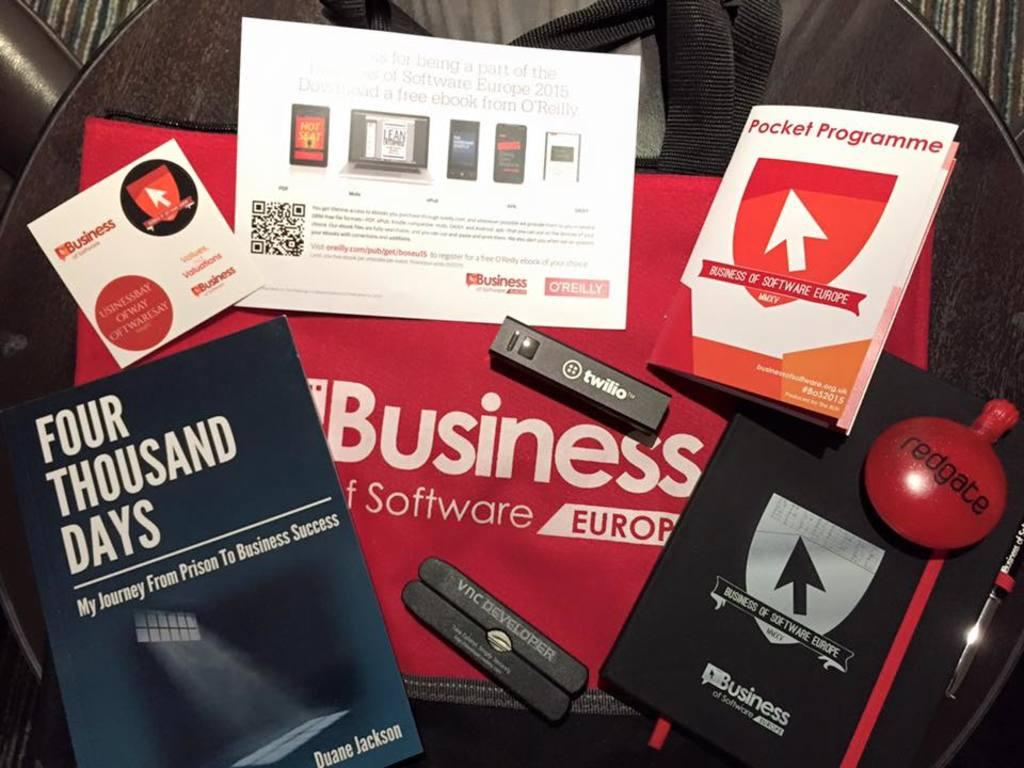<image>
Render a clear and concise summary of the photo. Flyers and giveaways including one from Pocket Programme. 